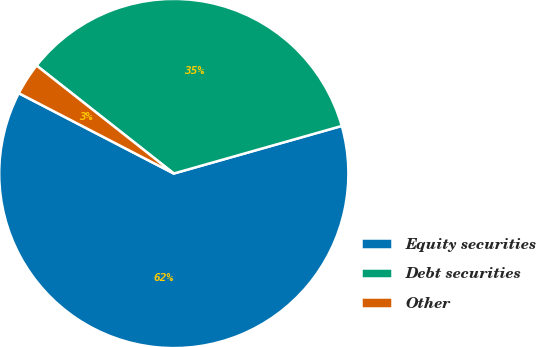Convert chart. <chart><loc_0><loc_0><loc_500><loc_500><pie_chart><fcel>Equity securities<fcel>Debt securities<fcel>Other<nl><fcel>62.0%<fcel>35.0%<fcel>3.0%<nl></chart> 